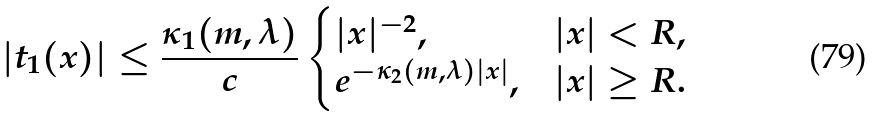Convert formula to latex. <formula><loc_0><loc_0><loc_500><loc_500>| t _ { 1 } ( x ) | \leq \frac { \kappa _ { 1 } ( m , \lambda ) } { c } \begin{cases} | x | ^ { - 2 } , & | x | < R , \\ e ^ { - \kappa _ { 2 } ( m , \lambda ) | x | } , & | x | \geq R . \end{cases}</formula> 